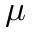Convert formula to latex. <formula><loc_0><loc_0><loc_500><loc_500>\mu</formula> 